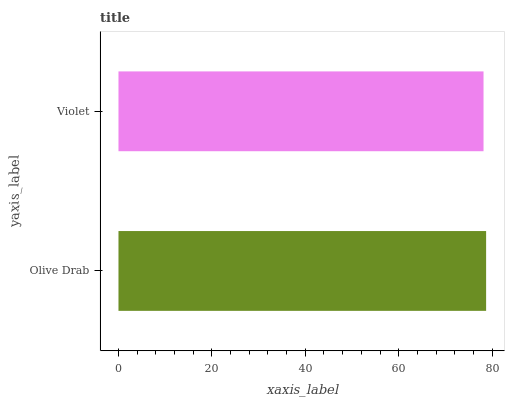Is Violet the minimum?
Answer yes or no. Yes. Is Olive Drab the maximum?
Answer yes or no. Yes. Is Violet the maximum?
Answer yes or no. No. Is Olive Drab greater than Violet?
Answer yes or no. Yes. Is Violet less than Olive Drab?
Answer yes or no. Yes. Is Violet greater than Olive Drab?
Answer yes or no. No. Is Olive Drab less than Violet?
Answer yes or no. No. Is Olive Drab the high median?
Answer yes or no. Yes. Is Violet the low median?
Answer yes or no. Yes. Is Violet the high median?
Answer yes or no. No. Is Olive Drab the low median?
Answer yes or no. No. 